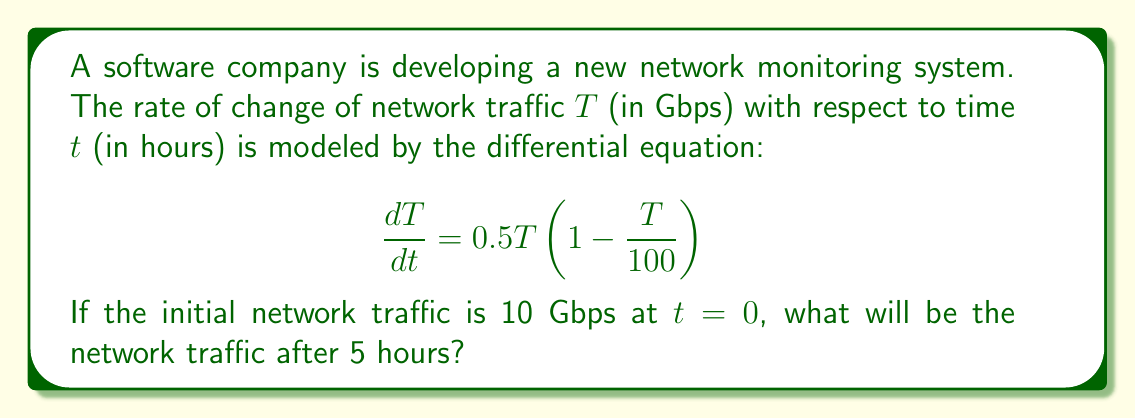Show me your answer to this math problem. To solve this problem, we need to use the logistic growth model, which is commonly used in network traffic analysis. Let's approach this step-by-step:

1) The given differential equation is in the form of the logistic growth model:

   $$\frac{dT}{dt} = rT(1 - \frac{T}{K})$$

   where $r = 0.5$ is the growth rate and $K = 100$ is the carrying capacity.

2) The solution to this differential equation is:

   $$T(t) = \frac{K}{1 + (\frac{K}{T_0} - 1)e^{-rt}}$$

   where $T_0$ is the initial traffic.

3) We're given that $T_0 = 10$, $K = 100$, $r = 0.5$, and we need to find $T(5)$.

4) Substituting these values into the solution:

   $$T(5) = \frac{100}{1 + (\frac{100}{10} - 1)e^{-0.5(5)}}$$

5) Simplify:
   
   $$T(5) = \frac{100}{1 + 9e^{-2.5}}$$

6) Calculate $e^{-2.5} \approx 0.0821$:

   $$T(5) = \frac{100}{1 + 9(0.0821)} \approx \frac{100}{1.7389}$$

7) Finally:

   $$T(5) \approx 57.51$$

Therefore, after 5 hours, the network traffic will be approximately 57.51 Gbps.
Answer: 57.51 Gbps 